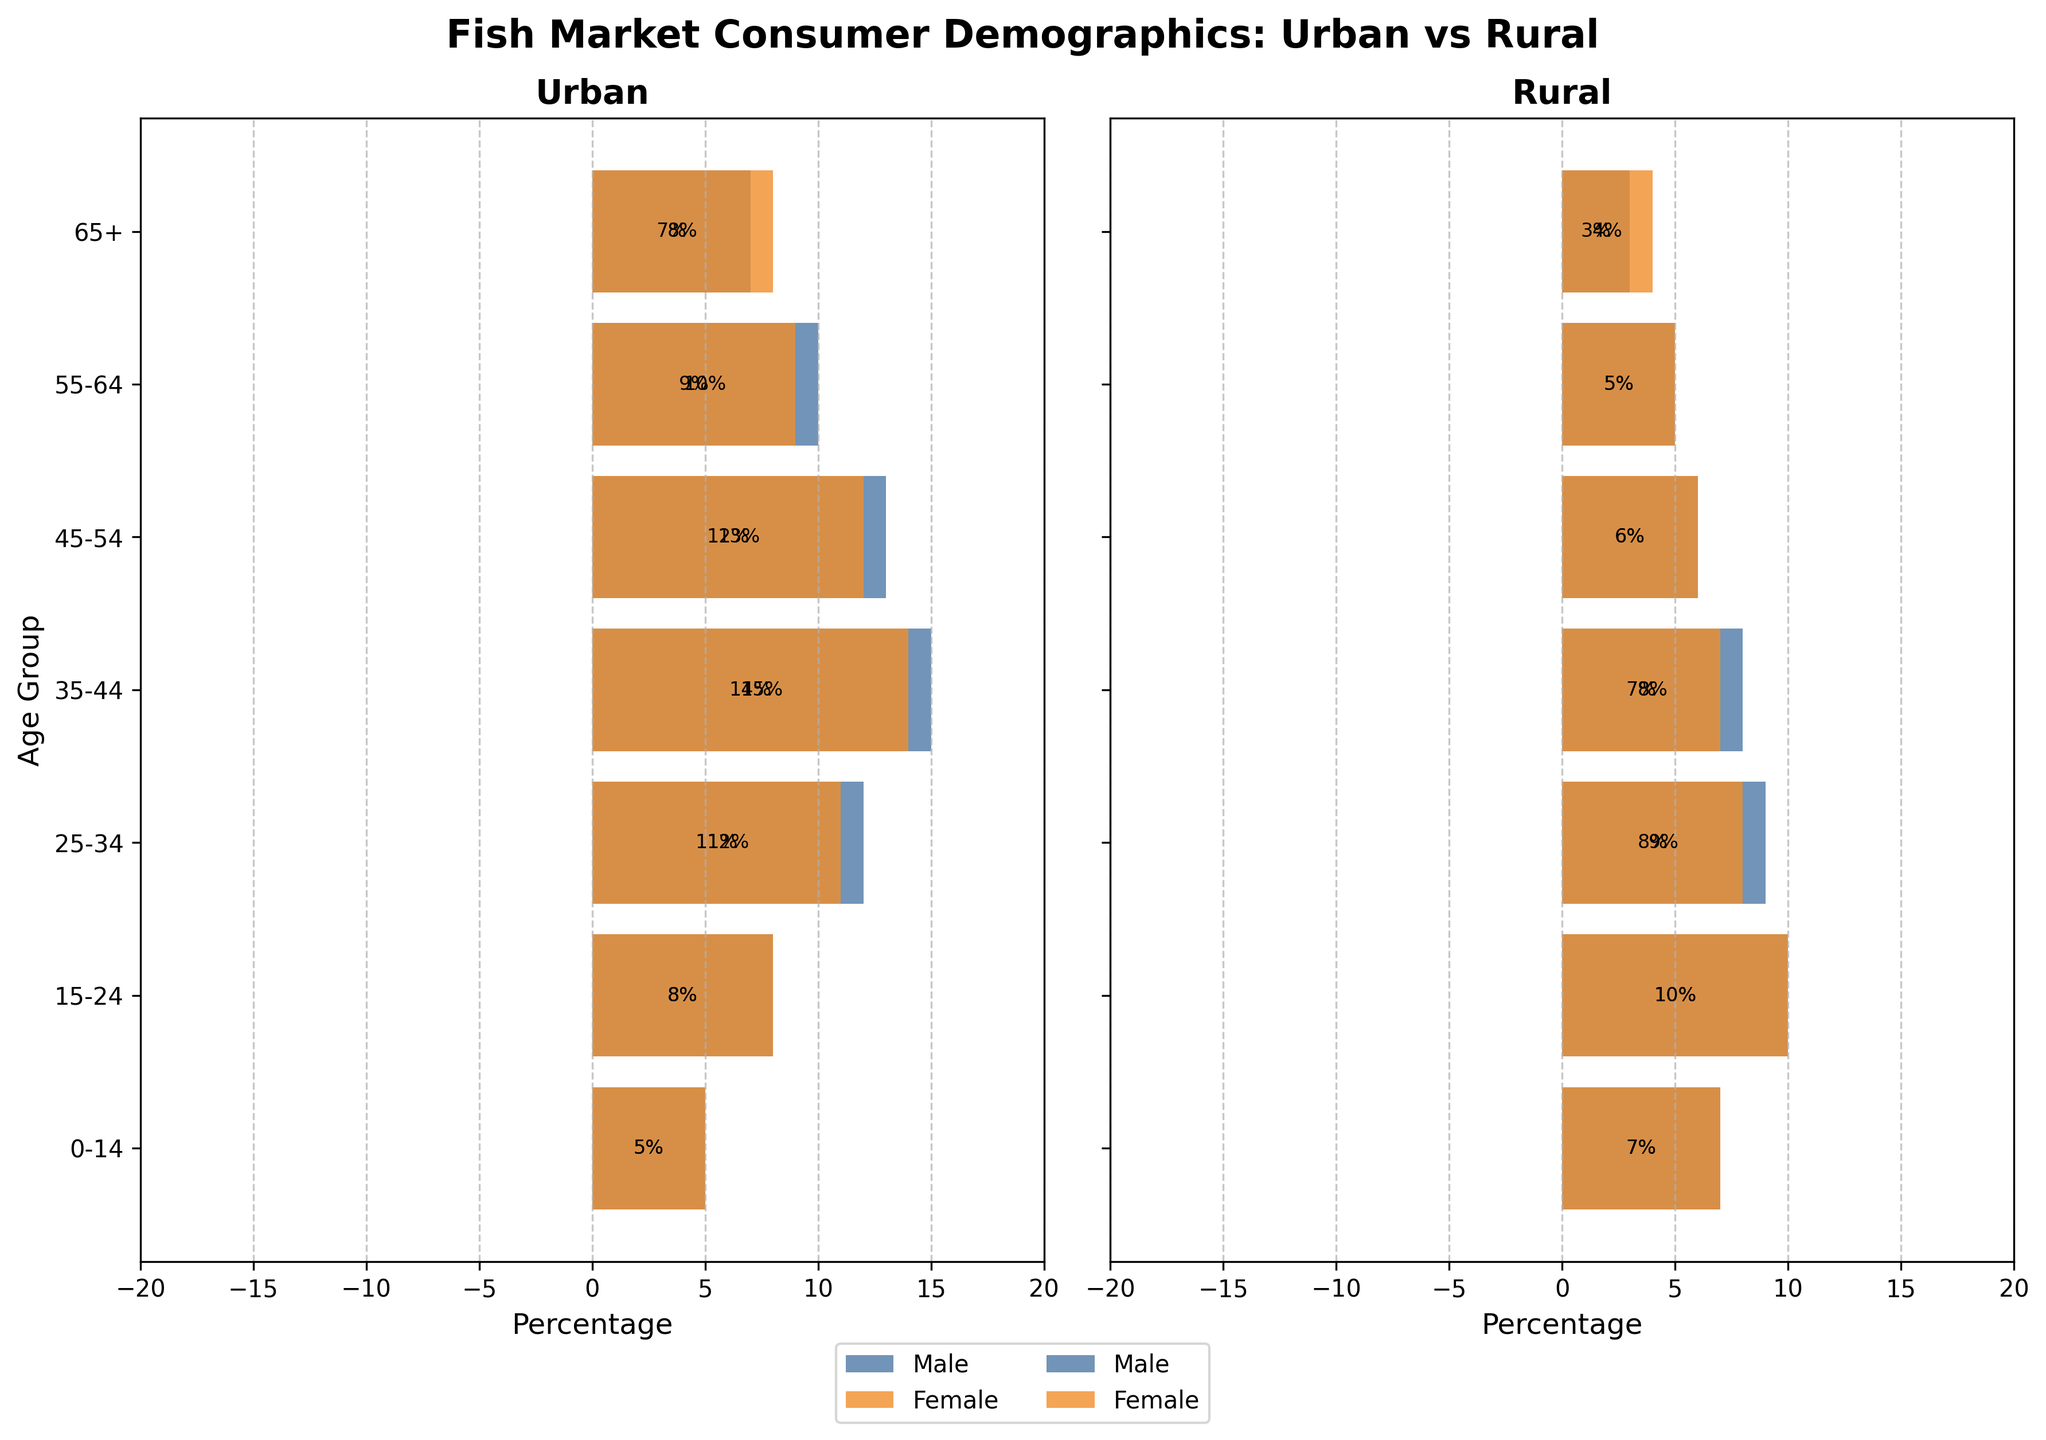What is the title of the figure? The title of the figure is located at the top center and reads "Fish Market Consumer Demographics: Urban vs Rural".
Answer: Fish Market Consumer Demographics: Urban vs Rural Which age group has the largest percentage of urban male consumers? In the Urban section, the bar for the 35-44 age group extends the furthest to the left for males, indicating it has the largest percentage.
Answer: 35-44 How many age groups are represented in the figure? The vertical axis lists all the age groups. Counting them reveals there are 7 age groups.
Answer: 7 In the rural area, which gender has the higher percentage in the 65+ age group? Checking the 65+ age group in the Rural section, the bar for females extends further to the right compared to males.
Answer: Female What is the total percentage of urban consumers in the 25-34 age group? To find the total percentage, add the absolute values of the urban male and female consumers in the 25-34 age group (-12 + 11)
Answer: 23% Which gender in rural areas has a higher percentage of consumers aged 15-24? In the Rural section, for the 15-24 age group, the female bar extends further to the right compared to the male bar.
Answer: Female What is the difference in percentage between urban and rural consumers aged 0-14? For the 0-14 age group, the total percentage for urban consumers is (-5 + 5) = 10%, and for rural consumers, it is (-7 + 7) = 14%. The difference is
Answer: 4% Compare the percentages of urban and rural male consumers in the 55-64 age group. In the 55-64 age group, the urban male percentage is 10% (given negatively in the figure), and the rural male percentage is 5%.
Answer: Urban males have a higher percentage by 5% What is the percentage difference between rural male and female consumers in the 45-54 age group? The Rural section indicates 6% for males and 6% for females in the 45-54 age group. The difference is 0%.
Answer: 0% Which age group has the smallest percentage difference between urban and rural female consumers? By comparing the female bars for each age group in Urban and Rural sections, the 65+ age group shows a small difference: 8% (Urban) and 4% (Rural), which gives 4%.
Answer: 65+ 